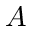Convert formula to latex. <formula><loc_0><loc_0><loc_500><loc_500>A</formula> 